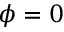<formula> <loc_0><loc_0><loc_500><loc_500>\phi = 0</formula> 